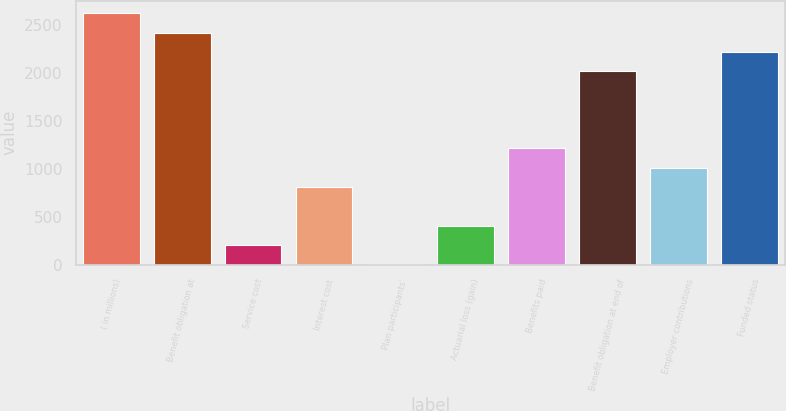Convert chart to OTSL. <chart><loc_0><loc_0><loc_500><loc_500><bar_chart><fcel>( in millions)<fcel>Benefit obligation at<fcel>Service cost<fcel>Interest cost<fcel>Plan participants'<fcel>Actuarial loss (gain)<fcel>Benefits paid<fcel>Benefit obligation at end of<fcel>Employer contributions<fcel>Funded status<nl><fcel>2619.7<fcel>2418.8<fcel>208.9<fcel>811.6<fcel>8<fcel>409.8<fcel>1213.4<fcel>2017<fcel>1012.5<fcel>2217.9<nl></chart> 